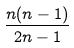Convert formula to latex. <formula><loc_0><loc_0><loc_500><loc_500>\frac { n ( n - 1 ) } { 2 n - 1 }</formula> 